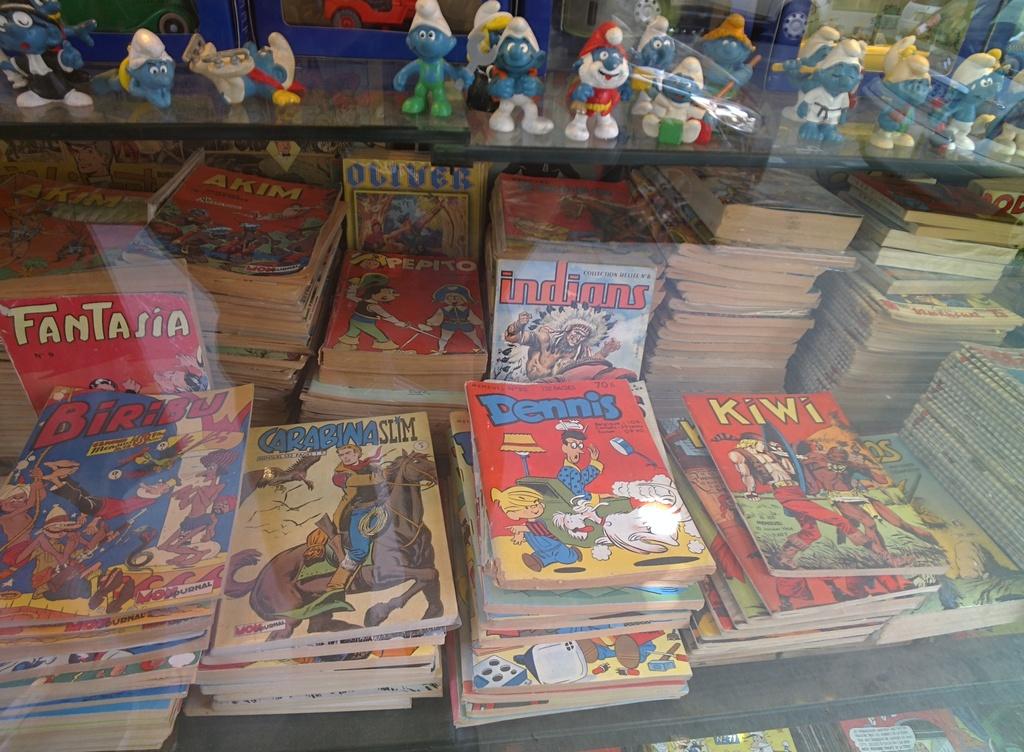What is the title of the red comic book with blue lettering?
Your answer should be compact. Dennis. What is the name of the comic book with the horse on it?
Make the answer very short. Carabina slim. 